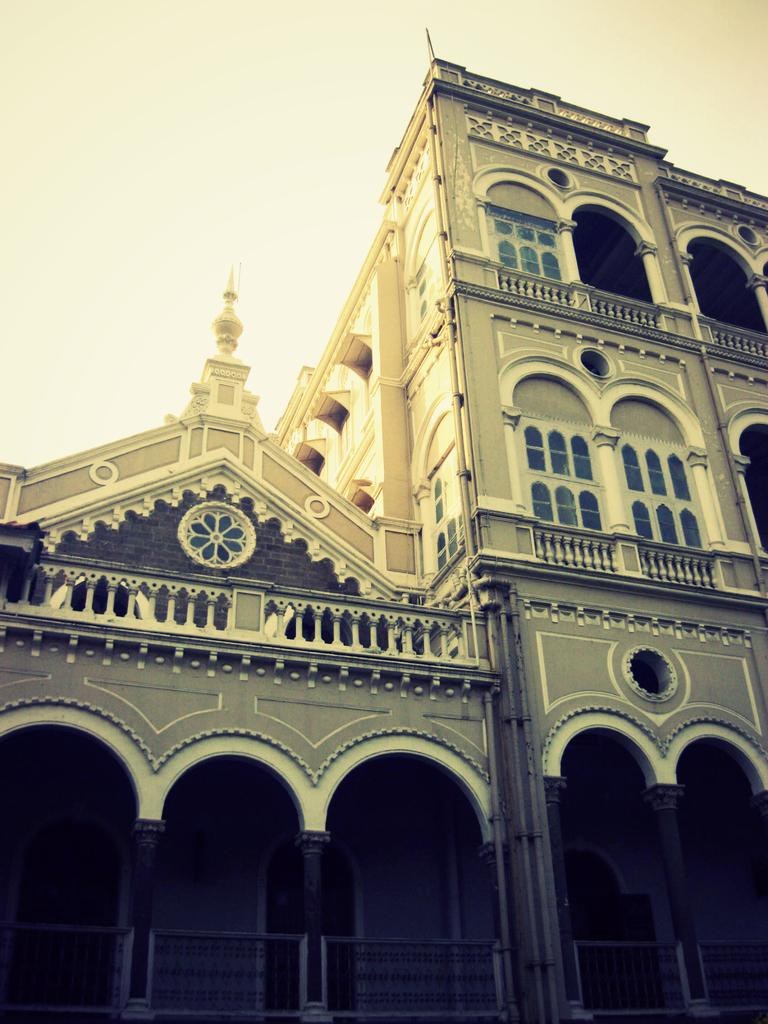What type of structure is present in the image? There is a building in the image. What architectural features can be seen on the building? The building has pillars, walls, windows, and railings at the bottom. What can be seen in the background of the image? The sky is visible in the background of the image. What type of fruit is being used as a receipt for the battle in the image? There is no fruit, receipt, or battle present in the image. 